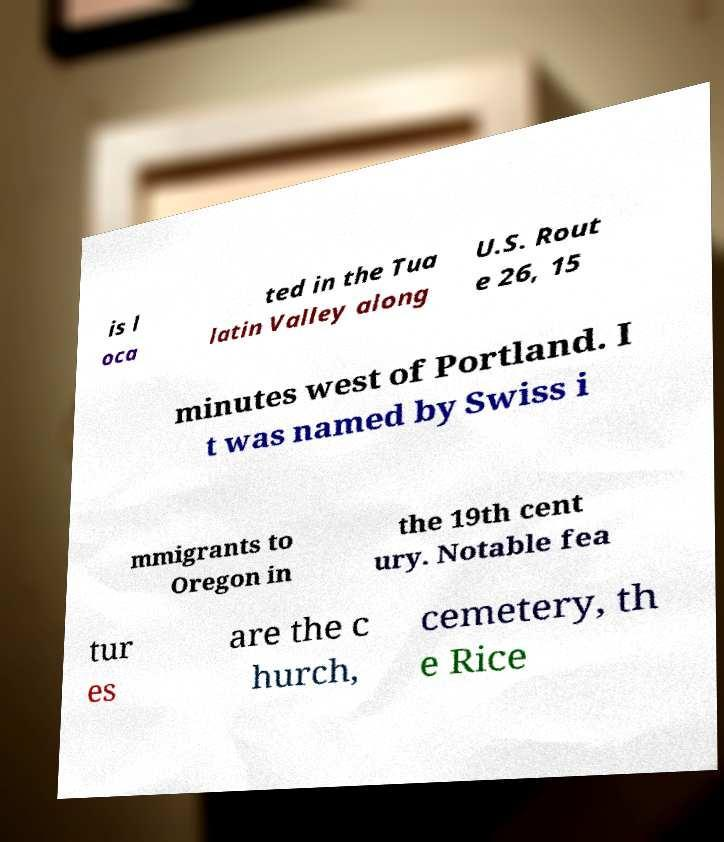For documentation purposes, I need the text within this image transcribed. Could you provide that? is l oca ted in the Tua latin Valley along U.S. Rout e 26, 15 minutes west of Portland. I t was named by Swiss i mmigrants to Oregon in the 19th cent ury. Notable fea tur es are the c hurch, cemetery, th e Rice 